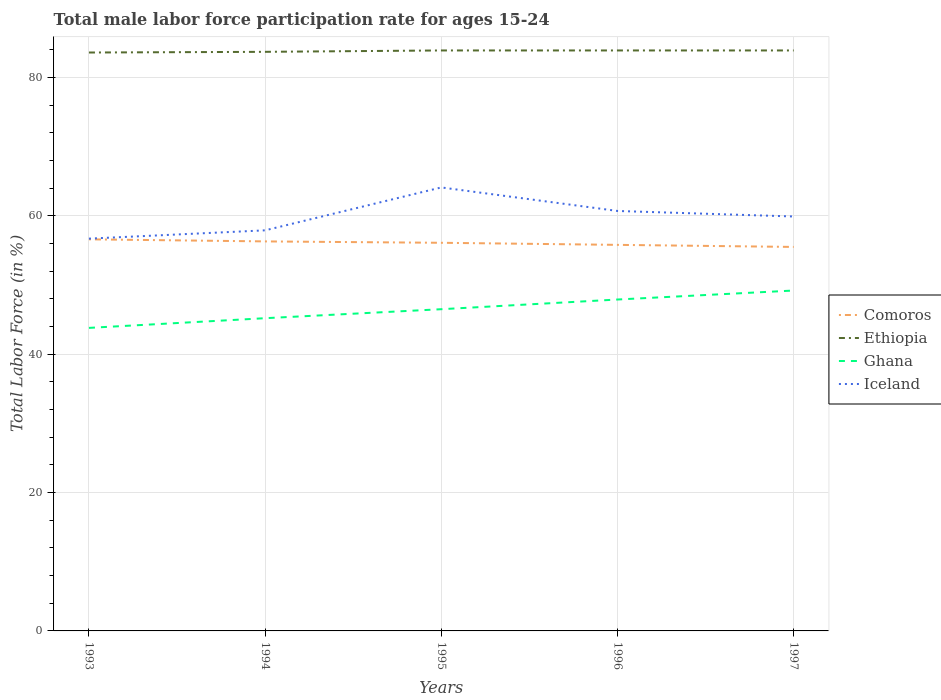How many different coloured lines are there?
Your answer should be compact. 4. Does the line corresponding to Iceland intersect with the line corresponding to Ethiopia?
Your answer should be compact. No. Across all years, what is the maximum male labor force participation rate in Ghana?
Give a very brief answer. 43.8. In which year was the male labor force participation rate in Ethiopia maximum?
Make the answer very short. 1993. What is the total male labor force participation rate in Ethiopia in the graph?
Make the answer very short. -0.3. What is the difference between the highest and the second highest male labor force participation rate in Comoros?
Make the answer very short. 1.1. What is the difference between the highest and the lowest male labor force participation rate in Iceland?
Provide a short and direct response. 3. Is the male labor force participation rate in Ghana strictly greater than the male labor force participation rate in Ethiopia over the years?
Your answer should be compact. Yes. Are the values on the major ticks of Y-axis written in scientific E-notation?
Give a very brief answer. No. Does the graph contain any zero values?
Offer a terse response. No. Does the graph contain grids?
Give a very brief answer. Yes. Where does the legend appear in the graph?
Keep it short and to the point. Center right. What is the title of the graph?
Ensure brevity in your answer.  Total male labor force participation rate for ages 15-24. Does "Hong Kong" appear as one of the legend labels in the graph?
Keep it short and to the point. No. What is the label or title of the X-axis?
Ensure brevity in your answer.  Years. What is the label or title of the Y-axis?
Your response must be concise. Total Labor Force (in %). What is the Total Labor Force (in %) of Comoros in 1993?
Keep it short and to the point. 56.6. What is the Total Labor Force (in %) of Ethiopia in 1993?
Give a very brief answer. 83.6. What is the Total Labor Force (in %) in Ghana in 1993?
Offer a very short reply. 43.8. What is the Total Labor Force (in %) in Iceland in 1993?
Keep it short and to the point. 56.7. What is the Total Labor Force (in %) in Comoros in 1994?
Give a very brief answer. 56.3. What is the Total Labor Force (in %) in Ethiopia in 1994?
Provide a succinct answer. 83.7. What is the Total Labor Force (in %) of Ghana in 1994?
Keep it short and to the point. 45.2. What is the Total Labor Force (in %) of Iceland in 1994?
Provide a short and direct response. 57.9. What is the Total Labor Force (in %) in Comoros in 1995?
Offer a terse response. 56.1. What is the Total Labor Force (in %) of Ethiopia in 1995?
Give a very brief answer. 83.9. What is the Total Labor Force (in %) of Ghana in 1995?
Your answer should be compact. 46.5. What is the Total Labor Force (in %) of Iceland in 1995?
Your answer should be compact. 64.1. What is the Total Labor Force (in %) in Comoros in 1996?
Your response must be concise. 55.8. What is the Total Labor Force (in %) in Ethiopia in 1996?
Provide a succinct answer. 83.9. What is the Total Labor Force (in %) in Ghana in 1996?
Your answer should be very brief. 47.9. What is the Total Labor Force (in %) in Iceland in 1996?
Offer a terse response. 60.7. What is the Total Labor Force (in %) in Comoros in 1997?
Offer a terse response. 55.5. What is the Total Labor Force (in %) of Ethiopia in 1997?
Offer a terse response. 83.9. What is the Total Labor Force (in %) of Ghana in 1997?
Ensure brevity in your answer.  49.2. What is the Total Labor Force (in %) in Iceland in 1997?
Give a very brief answer. 59.9. Across all years, what is the maximum Total Labor Force (in %) in Comoros?
Give a very brief answer. 56.6. Across all years, what is the maximum Total Labor Force (in %) of Ethiopia?
Provide a succinct answer. 83.9. Across all years, what is the maximum Total Labor Force (in %) in Ghana?
Give a very brief answer. 49.2. Across all years, what is the maximum Total Labor Force (in %) in Iceland?
Offer a terse response. 64.1. Across all years, what is the minimum Total Labor Force (in %) of Comoros?
Your response must be concise. 55.5. Across all years, what is the minimum Total Labor Force (in %) in Ethiopia?
Offer a terse response. 83.6. Across all years, what is the minimum Total Labor Force (in %) in Ghana?
Your answer should be compact. 43.8. Across all years, what is the minimum Total Labor Force (in %) in Iceland?
Offer a terse response. 56.7. What is the total Total Labor Force (in %) of Comoros in the graph?
Ensure brevity in your answer.  280.3. What is the total Total Labor Force (in %) of Ethiopia in the graph?
Keep it short and to the point. 419. What is the total Total Labor Force (in %) of Ghana in the graph?
Provide a succinct answer. 232.6. What is the total Total Labor Force (in %) of Iceland in the graph?
Keep it short and to the point. 299.3. What is the difference between the Total Labor Force (in %) in Ethiopia in 1993 and that in 1994?
Your answer should be compact. -0.1. What is the difference between the Total Labor Force (in %) in Ghana in 1993 and that in 1996?
Provide a short and direct response. -4.1. What is the difference between the Total Labor Force (in %) in Comoros in 1993 and that in 1997?
Your answer should be compact. 1.1. What is the difference between the Total Labor Force (in %) of Ethiopia in 1993 and that in 1997?
Your answer should be compact. -0.3. What is the difference between the Total Labor Force (in %) in Ghana in 1993 and that in 1997?
Offer a terse response. -5.4. What is the difference between the Total Labor Force (in %) in Ethiopia in 1994 and that in 1995?
Provide a succinct answer. -0.2. What is the difference between the Total Labor Force (in %) in Comoros in 1994 and that in 1996?
Give a very brief answer. 0.5. What is the difference between the Total Labor Force (in %) in Ethiopia in 1994 and that in 1996?
Offer a very short reply. -0.2. What is the difference between the Total Labor Force (in %) in Comoros in 1994 and that in 1997?
Offer a terse response. 0.8. What is the difference between the Total Labor Force (in %) in Ghana in 1994 and that in 1997?
Provide a short and direct response. -4. What is the difference between the Total Labor Force (in %) in Iceland in 1994 and that in 1997?
Keep it short and to the point. -2. What is the difference between the Total Labor Force (in %) in Ethiopia in 1995 and that in 1996?
Offer a terse response. 0. What is the difference between the Total Labor Force (in %) in Ghana in 1995 and that in 1996?
Your response must be concise. -1.4. What is the difference between the Total Labor Force (in %) of Iceland in 1995 and that in 1996?
Provide a succinct answer. 3.4. What is the difference between the Total Labor Force (in %) in Ethiopia in 1995 and that in 1997?
Give a very brief answer. 0. What is the difference between the Total Labor Force (in %) in Ghana in 1995 and that in 1997?
Your answer should be compact. -2.7. What is the difference between the Total Labor Force (in %) in Iceland in 1995 and that in 1997?
Provide a succinct answer. 4.2. What is the difference between the Total Labor Force (in %) in Ethiopia in 1996 and that in 1997?
Give a very brief answer. 0. What is the difference between the Total Labor Force (in %) of Comoros in 1993 and the Total Labor Force (in %) of Ethiopia in 1994?
Make the answer very short. -27.1. What is the difference between the Total Labor Force (in %) of Comoros in 1993 and the Total Labor Force (in %) of Ghana in 1994?
Provide a succinct answer. 11.4. What is the difference between the Total Labor Force (in %) of Comoros in 1993 and the Total Labor Force (in %) of Iceland in 1994?
Your response must be concise. -1.3. What is the difference between the Total Labor Force (in %) of Ethiopia in 1993 and the Total Labor Force (in %) of Ghana in 1994?
Offer a terse response. 38.4. What is the difference between the Total Labor Force (in %) in Ethiopia in 1993 and the Total Labor Force (in %) in Iceland in 1994?
Your response must be concise. 25.7. What is the difference between the Total Labor Force (in %) in Ghana in 1993 and the Total Labor Force (in %) in Iceland in 1994?
Provide a short and direct response. -14.1. What is the difference between the Total Labor Force (in %) of Comoros in 1993 and the Total Labor Force (in %) of Ethiopia in 1995?
Offer a very short reply. -27.3. What is the difference between the Total Labor Force (in %) in Comoros in 1993 and the Total Labor Force (in %) in Iceland in 1995?
Your response must be concise. -7.5. What is the difference between the Total Labor Force (in %) of Ethiopia in 1993 and the Total Labor Force (in %) of Ghana in 1995?
Provide a succinct answer. 37.1. What is the difference between the Total Labor Force (in %) of Ghana in 1993 and the Total Labor Force (in %) of Iceland in 1995?
Your answer should be compact. -20.3. What is the difference between the Total Labor Force (in %) of Comoros in 1993 and the Total Labor Force (in %) of Ethiopia in 1996?
Give a very brief answer. -27.3. What is the difference between the Total Labor Force (in %) in Ethiopia in 1993 and the Total Labor Force (in %) in Ghana in 1996?
Offer a very short reply. 35.7. What is the difference between the Total Labor Force (in %) in Ethiopia in 1993 and the Total Labor Force (in %) in Iceland in 1996?
Offer a very short reply. 22.9. What is the difference between the Total Labor Force (in %) in Ghana in 1993 and the Total Labor Force (in %) in Iceland in 1996?
Ensure brevity in your answer.  -16.9. What is the difference between the Total Labor Force (in %) in Comoros in 1993 and the Total Labor Force (in %) in Ethiopia in 1997?
Keep it short and to the point. -27.3. What is the difference between the Total Labor Force (in %) in Comoros in 1993 and the Total Labor Force (in %) in Ghana in 1997?
Keep it short and to the point. 7.4. What is the difference between the Total Labor Force (in %) of Comoros in 1993 and the Total Labor Force (in %) of Iceland in 1997?
Provide a short and direct response. -3.3. What is the difference between the Total Labor Force (in %) of Ethiopia in 1993 and the Total Labor Force (in %) of Ghana in 1997?
Offer a very short reply. 34.4. What is the difference between the Total Labor Force (in %) of Ethiopia in 1993 and the Total Labor Force (in %) of Iceland in 1997?
Your answer should be compact. 23.7. What is the difference between the Total Labor Force (in %) of Ghana in 1993 and the Total Labor Force (in %) of Iceland in 1997?
Your response must be concise. -16.1. What is the difference between the Total Labor Force (in %) in Comoros in 1994 and the Total Labor Force (in %) in Ethiopia in 1995?
Give a very brief answer. -27.6. What is the difference between the Total Labor Force (in %) of Comoros in 1994 and the Total Labor Force (in %) of Iceland in 1995?
Your answer should be very brief. -7.8. What is the difference between the Total Labor Force (in %) in Ethiopia in 1994 and the Total Labor Force (in %) in Ghana in 1995?
Make the answer very short. 37.2. What is the difference between the Total Labor Force (in %) in Ethiopia in 1994 and the Total Labor Force (in %) in Iceland in 1995?
Offer a terse response. 19.6. What is the difference between the Total Labor Force (in %) of Ghana in 1994 and the Total Labor Force (in %) of Iceland in 1995?
Make the answer very short. -18.9. What is the difference between the Total Labor Force (in %) of Comoros in 1994 and the Total Labor Force (in %) of Ethiopia in 1996?
Make the answer very short. -27.6. What is the difference between the Total Labor Force (in %) in Comoros in 1994 and the Total Labor Force (in %) in Ghana in 1996?
Your answer should be very brief. 8.4. What is the difference between the Total Labor Force (in %) of Ethiopia in 1994 and the Total Labor Force (in %) of Ghana in 1996?
Offer a very short reply. 35.8. What is the difference between the Total Labor Force (in %) of Ethiopia in 1994 and the Total Labor Force (in %) of Iceland in 1996?
Make the answer very short. 23. What is the difference between the Total Labor Force (in %) in Ghana in 1994 and the Total Labor Force (in %) in Iceland in 1996?
Your answer should be very brief. -15.5. What is the difference between the Total Labor Force (in %) of Comoros in 1994 and the Total Labor Force (in %) of Ethiopia in 1997?
Make the answer very short. -27.6. What is the difference between the Total Labor Force (in %) in Comoros in 1994 and the Total Labor Force (in %) in Iceland in 1997?
Provide a succinct answer. -3.6. What is the difference between the Total Labor Force (in %) of Ethiopia in 1994 and the Total Labor Force (in %) of Ghana in 1997?
Provide a short and direct response. 34.5. What is the difference between the Total Labor Force (in %) of Ethiopia in 1994 and the Total Labor Force (in %) of Iceland in 1997?
Ensure brevity in your answer.  23.8. What is the difference between the Total Labor Force (in %) in Ghana in 1994 and the Total Labor Force (in %) in Iceland in 1997?
Offer a terse response. -14.7. What is the difference between the Total Labor Force (in %) in Comoros in 1995 and the Total Labor Force (in %) in Ethiopia in 1996?
Offer a very short reply. -27.8. What is the difference between the Total Labor Force (in %) in Comoros in 1995 and the Total Labor Force (in %) in Ghana in 1996?
Offer a terse response. 8.2. What is the difference between the Total Labor Force (in %) of Comoros in 1995 and the Total Labor Force (in %) of Iceland in 1996?
Give a very brief answer. -4.6. What is the difference between the Total Labor Force (in %) in Ethiopia in 1995 and the Total Labor Force (in %) in Iceland in 1996?
Provide a short and direct response. 23.2. What is the difference between the Total Labor Force (in %) in Comoros in 1995 and the Total Labor Force (in %) in Ethiopia in 1997?
Ensure brevity in your answer.  -27.8. What is the difference between the Total Labor Force (in %) of Comoros in 1995 and the Total Labor Force (in %) of Ghana in 1997?
Ensure brevity in your answer.  6.9. What is the difference between the Total Labor Force (in %) of Comoros in 1995 and the Total Labor Force (in %) of Iceland in 1997?
Your answer should be compact. -3.8. What is the difference between the Total Labor Force (in %) of Ethiopia in 1995 and the Total Labor Force (in %) of Ghana in 1997?
Provide a short and direct response. 34.7. What is the difference between the Total Labor Force (in %) of Comoros in 1996 and the Total Labor Force (in %) of Ethiopia in 1997?
Provide a short and direct response. -28.1. What is the difference between the Total Labor Force (in %) in Ethiopia in 1996 and the Total Labor Force (in %) in Ghana in 1997?
Make the answer very short. 34.7. What is the difference between the Total Labor Force (in %) of Ghana in 1996 and the Total Labor Force (in %) of Iceland in 1997?
Make the answer very short. -12. What is the average Total Labor Force (in %) in Comoros per year?
Offer a very short reply. 56.06. What is the average Total Labor Force (in %) in Ethiopia per year?
Give a very brief answer. 83.8. What is the average Total Labor Force (in %) in Ghana per year?
Make the answer very short. 46.52. What is the average Total Labor Force (in %) in Iceland per year?
Ensure brevity in your answer.  59.86. In the year 1993, what is the difference between the Total Labor Force (in %) of Comoros and Total Labor Force (in %) of Ghana?
Your answer should be very brief. 12.8. In the year 1993, what is the difference between the Total Labor Force (in %) in Ethiopia and Total Labor Force (in %) in Ghana?
Your answer should be very brief. 39.8. In the year 1993, what is the difference between the Total Labor Force (in %) in Ethiopia and Total Labor Force (in %) in Iceland?
Your response must be concise. 26.9. In the year 1993, what is the difference between the Total Labor Force (in %) in Ghana and Total Labor Force (in %) in Iceland?
Your answer should be very brief. -12.9. In the year 1994, what is the difference between the Total Labor Force (in %) of Comoros and Total Labor Force (in %) of Ethiopia?
Your response must be concise. -27.4. In the year 1994, what is the difference between the Total Labor Force (in %) in Comoros and Total Labor Force (in %) in Ghana?
Your response must be concise. 11.1. In the year 1994, what is the difference between the Total Labor Force (in %) of Comoros and Total Labor Force (in %) of Iceland?
Give a very brief answer. -1.6. In the year 1994, what is the difference between the Total Labor Force (in %) of Ethiopia and Total Labor Force (in %) of Ghana?
Your answer should be compact. 38.5. In the year 1994, what is the difference between the Total Labor Force (in %) of Ethiopia and Total Labor Force (in %) of Iceland?
Your response must be concise. 25.8. In the year 1995, what is the difference between the Total Labor Force (in %) in Comoros and Total Labor Force (in %) in Ethiopia?
Provide a succinct answer. -27.8. In the year 1995, what is the difference between the Total Labor Force (in %) in Comoros and Total Labor Force (in %) in Iceland?
Keep it short and to the point. -8. In the year 1995, what is the difference between the Total Labor Force (in %) of Ethiopia and Total Labor Force (in %) of Ghana?
Provide a short and direct response. 37.4. In the year 1995, what is the difference between the Total Labor Force (in %) of Ethiopia and Total Labor Force (in %) of Iceland?
Make the answer very short. 19.8. In the year 1995, what is the difference between the Total Labor Force (in %) of Ghana and Total Labor Force (in %) of Iceland?
Provide a succinct answer. -17.6. In the year 1996, what is the difference between the Total Labor Force (in %) in Comoros and Total Labor Force (in %) in Ethiopia?
Provide a short and direct response. -28.1. In the year 1996, what is the difference between the Total Labor Force (in %) in Comoros and Total Labor Force (in %) in Ghana?
Provide a short and direct response. 7.9. In the year 1996, what is the difference between the Total Labor Force (in %) in Ethiopia and Total Labor Force (in %) in Ghana?
Keep it short and to the point. 36. In the year 1996, what is the difference between the Total Labor Force (in %) in Ethiopia and Total Labor Force (in %) in Iceland?
Your answer should be compact. 23.2. In the year 1996, what is the difference between the Total Labor Force (in %) in Ghana and Total Labor Force (in %) in Iceland?
Your answer should be very brief. -12.8. In the year 1997, what is the difference between the Total Labor Force (in %) in Comoros and Total Labor Force (in %) in Ethiopia?
Offer a terse response. -28.4. In the year 1997, what is the difference between the Total Labor Force (in %) of Comoros and Total Labor Force (in %) of Ghana?
Give a very brief answer. 6.3. In the year 1997, what is the difference between the Total Labor Force (in %) in Ethiopia and Total Labor Force (in %) in Ghana?
Give a very brief answer. 34.7. What is the ratio of the Total Labor Force (in %) in Comoros in 1993 to that in 1994?
Offer a terse response. 1.01. What is the ratio of the Total Labor Force (in %) of Iceland in 1993 to that in 1994?
Provide a short and direct response. 0.98. What is the ratio of the Total Labor Force (in %) in Comoros in 1993 to that in 1995?
Offer a very short reply. 1.01. What is the ratio of the Total Labor Force (in %) of Ethiopia in 1993 to that in 1995?
Your response must be concise. 1. What is the ratio of the Total Labor Force (in %) in Ghana in 1993 to that in 1995?
Keep it short and to the point. 0.94. What is the ratio of the Total Labor Force (in %) of Iceland in 1993 to that in 1995?
Keep it short and to the point. 0.88. What is the ratio of the Total Labor Force (in %) of Comoros in 1993 to that in 1996?
Your answer should be compact. 1.01. What is the ratio of the Total Labor Force (in %) in Ethiopia in 1993 to that in 1996?
Offer a terse response. 1. What is the ratio of the Total Labor Force (in %) of Ghana in 1993 to that in 1996?
Give a very brief answer. 0.91. What is the ratio of the Total Labor Force (in %) of Iceland in 1993 to that in 1996?
Your response must be concise. 0.93. What is the ratio of the Total Labor Force (in %) in Comoros in 1993 to that in 1997?
Provide a short and direct response. 1.02. What is the ratio of the Total Labor Force (in %) in Ghana in 1993 to that in 1997?
Keep it short and to the point. 0.89. What is the ratio of the Total Labor Force (in %) of Iceland in 1993 to that in 1997?
Keep it short and to the point. 0.95. What is the ratio of the Total Labor Force (in %) in Comoros in 1994 to that in 1995?
Provide a succinct answer. 1. What is the ratio of the Total Labor Force (in %) of Ghana in 1994 to that in 1995?
Your answer should be compact. 0.97. What is the ratio of the Total Labor Force (in %) of Iceland in 1994 to that in 1995?
Your answer should be compact. 0.9. What is the ratio of the Total Labor Force (in %) in Ghana in 1994 to that in 1996?
Ensure brevity in your answer.  0.94. What is the ratio of the Total Labor Force (in %) of Iceland in 1994 to that in 1996?
Provide a succinct answer. 0.95. What is the ratio of the Total Labor Force (in %) in Comoros in 1994 to that in 1997?
Provide a short and direct response. 1.01. What is the ratio of the Total Labor Force (in %) in Ghana in 1994 to that in 1997?
Your answer should be very brief. 0.92. What is the ratio of the Total Labor Force (in %) of Iceland in 1994 to that in 1997?
Ensure brevity in your answer.  0.97. What is the ratio of the Total Labor Force (in %) of Comoros in 1995 to that in 1996?
Provide a short and direct response. 1.01. What is the ratio of the Total Labor Force (in %) of Ethiopia in 1995 to that in 1996?
Your answer should be very brief. 1. What is the ratio of the Total Labor Force (in %) of Ghana in 1995 to that in 1996?
Your answer should be compact. 0.97. What is the ratio of the Total Labor Force (in %) of Iceland in 1995 to that in 1996?
Offer a terse response. 1.06. What is the ratio of the Total Labor Force (in %) in Comoros in 1995 to that in 1997?
Offer a terse response. 1.01. What is the ratio of the Total Labor Force (in %) of Ghana in 1995 to that in 1997?
Give a very brief answer. 0.95. What is the ratio of the Total Labor Force (in %) in Iceland in 1995 to that in 1997?
Your answer should be compact. 1.07. What is the ratio of the Total Labor Force (in %) in Comoros in 1996 to that in 1997?
Provide a short and direct response. 1.01. What is the ratio of the Total Labor Force (in %) of Ghana in 1996 to that in 1997?
Provide a short and direct response. 0.97. What is the ratio of the Total Labor Force (in %) in Iceland in 1996 to that in 1997?
Keep it short and to the point. 1.01. What is the difference between the highest and the second highest Total Labor Force (in %) of Iceland?
Provide a succinct answer. 3.4. What is the difference between the highest and the lowest Total Labor Force (in %) of Ghana?
Your response must be concise. 5.4. What is the difference between the highest and the lowest Total Labor Force (in %) of Iceland?
Your answer should be compact. 7.4. 